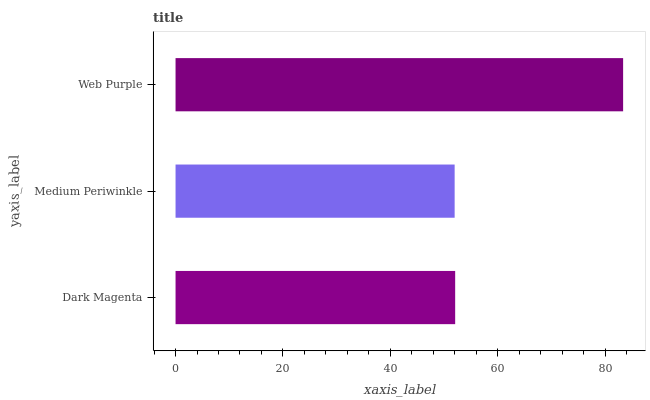Is Medium Periwinkle the minimum?
Answer yes or no. Yes. Is Web Purple the maximum?
Answer yes or no. Yes. Is Web Purple the minimum?
Answer yes or no. No. Is Medium Periwinkle the maximum?
Answer yes or no. No. Is Web Purple greater than Medium Periwinkle?
Answer yes or no. Yes. Is Medium Periwinkle less than Web Purple?
Answer yes or no. Yes. Is Medium Periwinkle greater than Web Purple?
Answer yes or no. No. Is Web Purple less than Medium Periwinkle?
Answer yes or no. No. Is Dark Magenta the high median?
Answer yes or no. Yes. Is Dark Magenta the low median?
Answer yes or no. Yes. Is Web Purple the high median?
Answer yes or no. No. Is Web Purple the low median?
Answer yes or no. No. 